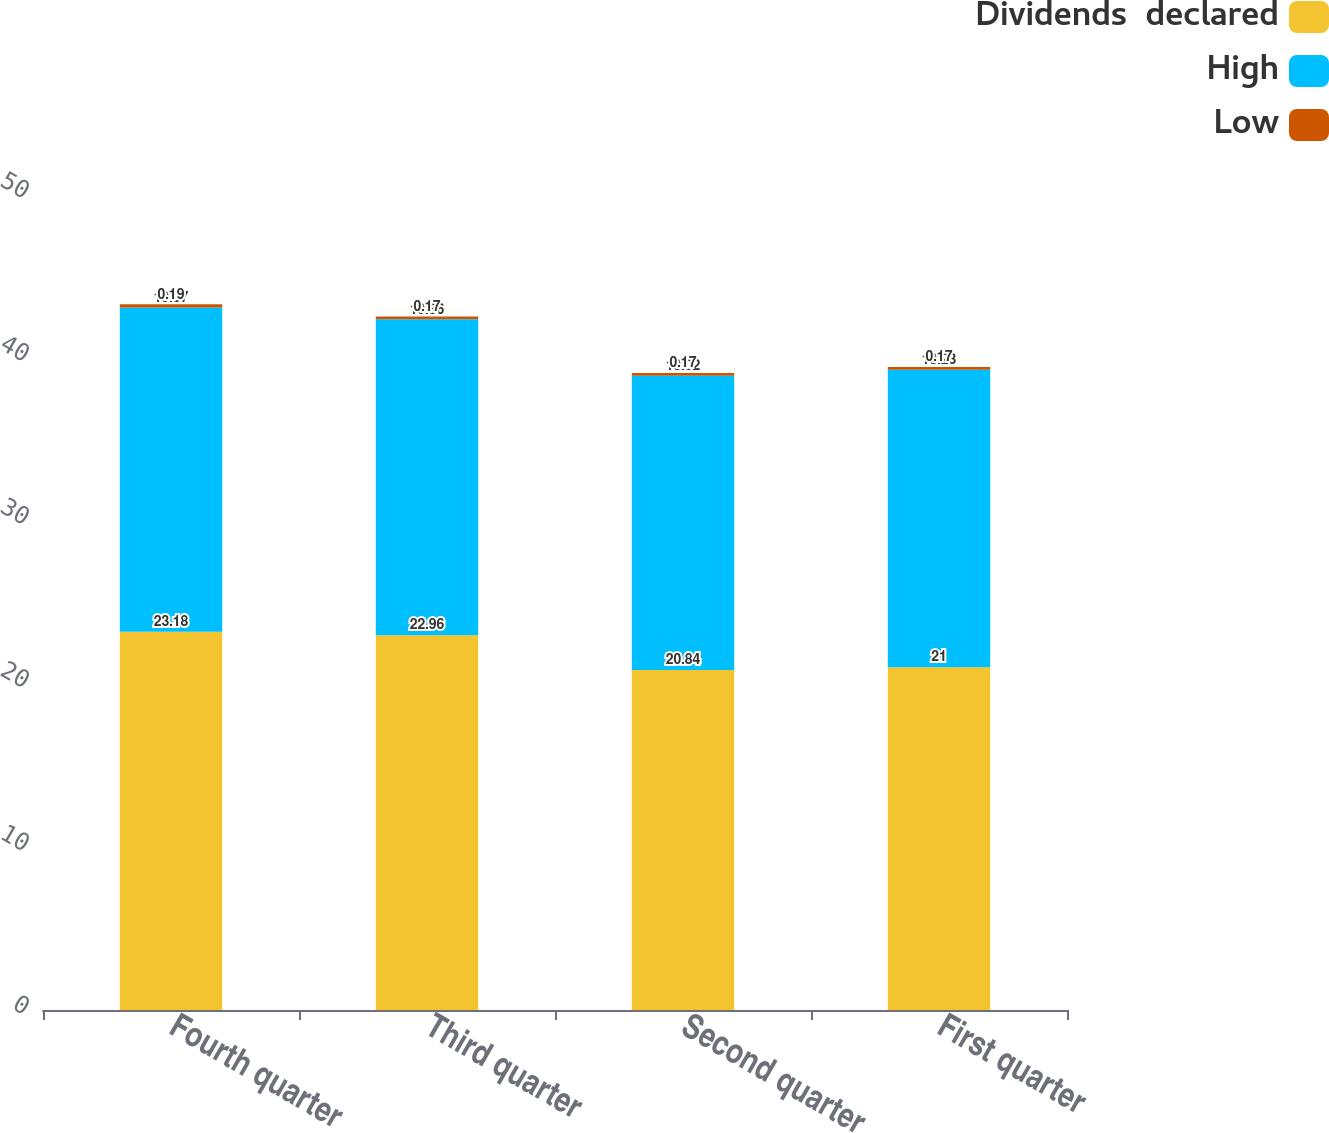Convert chart. <chart><loc_0><loc_0><loc_500><loc_500><stacked_bar_chart><ecel><fcel>Fourth quarter<fcel>Third quarter<fcel>Second quarter<fcel>First quarter<nl><fcel>Dividends  declared<fcel>23.18<fcel>22.96<fcel>20.84<fcel>21<nl><fcel>High<fcel>19.87<fcel>19.36<fcel>18.02<fcel>18.23<nl><fcel>Low<fcel>0.19<fcel>0.17<fcel>0.17<fcel>0.17<nl></chart> 